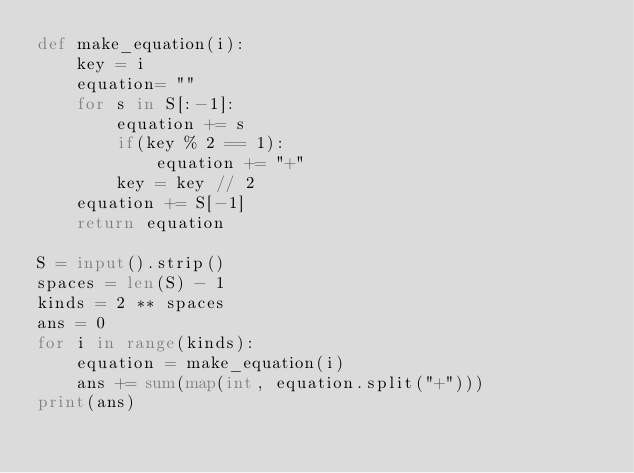Convert code to text. <code><loc_0><loc_0><loc_500><loc_500><_Python_>def make_equation(i):
    key = i
    equation= ""
    for s in S[:-1]:
        equation += s
        if(key % 2 == 1):
            equation += "+"
        key = key // 2
    equation += S[-1]
    return equation

S = input().strip()
spaces = len(S) - 1
kinds = 2 ** spaces
ans = 0
for i in range(kinds):
    equation = make_equation(i)    
    ans += sum(map(int, equation.split("+")))
print(ans)</code> 